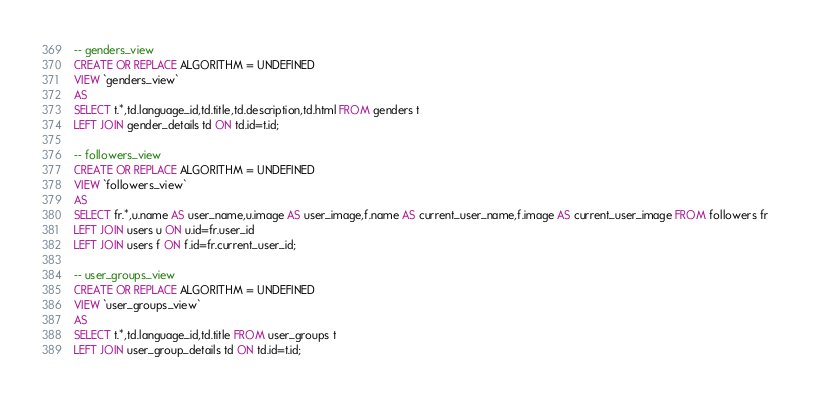Convert code to text. <code><loc_0><loc_0><loc_500><loc_500><_SQL_>-- genders_view
CREATE OR REPLACE ALGORITHM = UNDEFINED
VIEW `genders_view`
AS
SELECT t.*,td.language_id,td.title,td.description,td.html FROM genders t
LEFT JOIN gender_details td ON td.id=t.id;

-- followers_view
CREATE OR REPLACE ALGORITHM = UNDEFINED
VIEW `followers_view`
AS
SELECT fr.*,u.name AS user_name,u.image AS user_image,f.name AS current_user_name,f.image AS current_user_image FROM followers fr 
LEFT JOIN users u ON u.id=fr.user_id
LEFT JOIN users f ON f.id=fr.current_user_id;

-- user_groups_view
CREATE OR REPLACE ALGORITHM = UNDEFINED
VIEW `user_groups_view`
AS
SELECT t.*,td.language_id,td.title FROM user_groups t
LEFT JOIN user_group_details td ON td.id=t.id;

</code> 